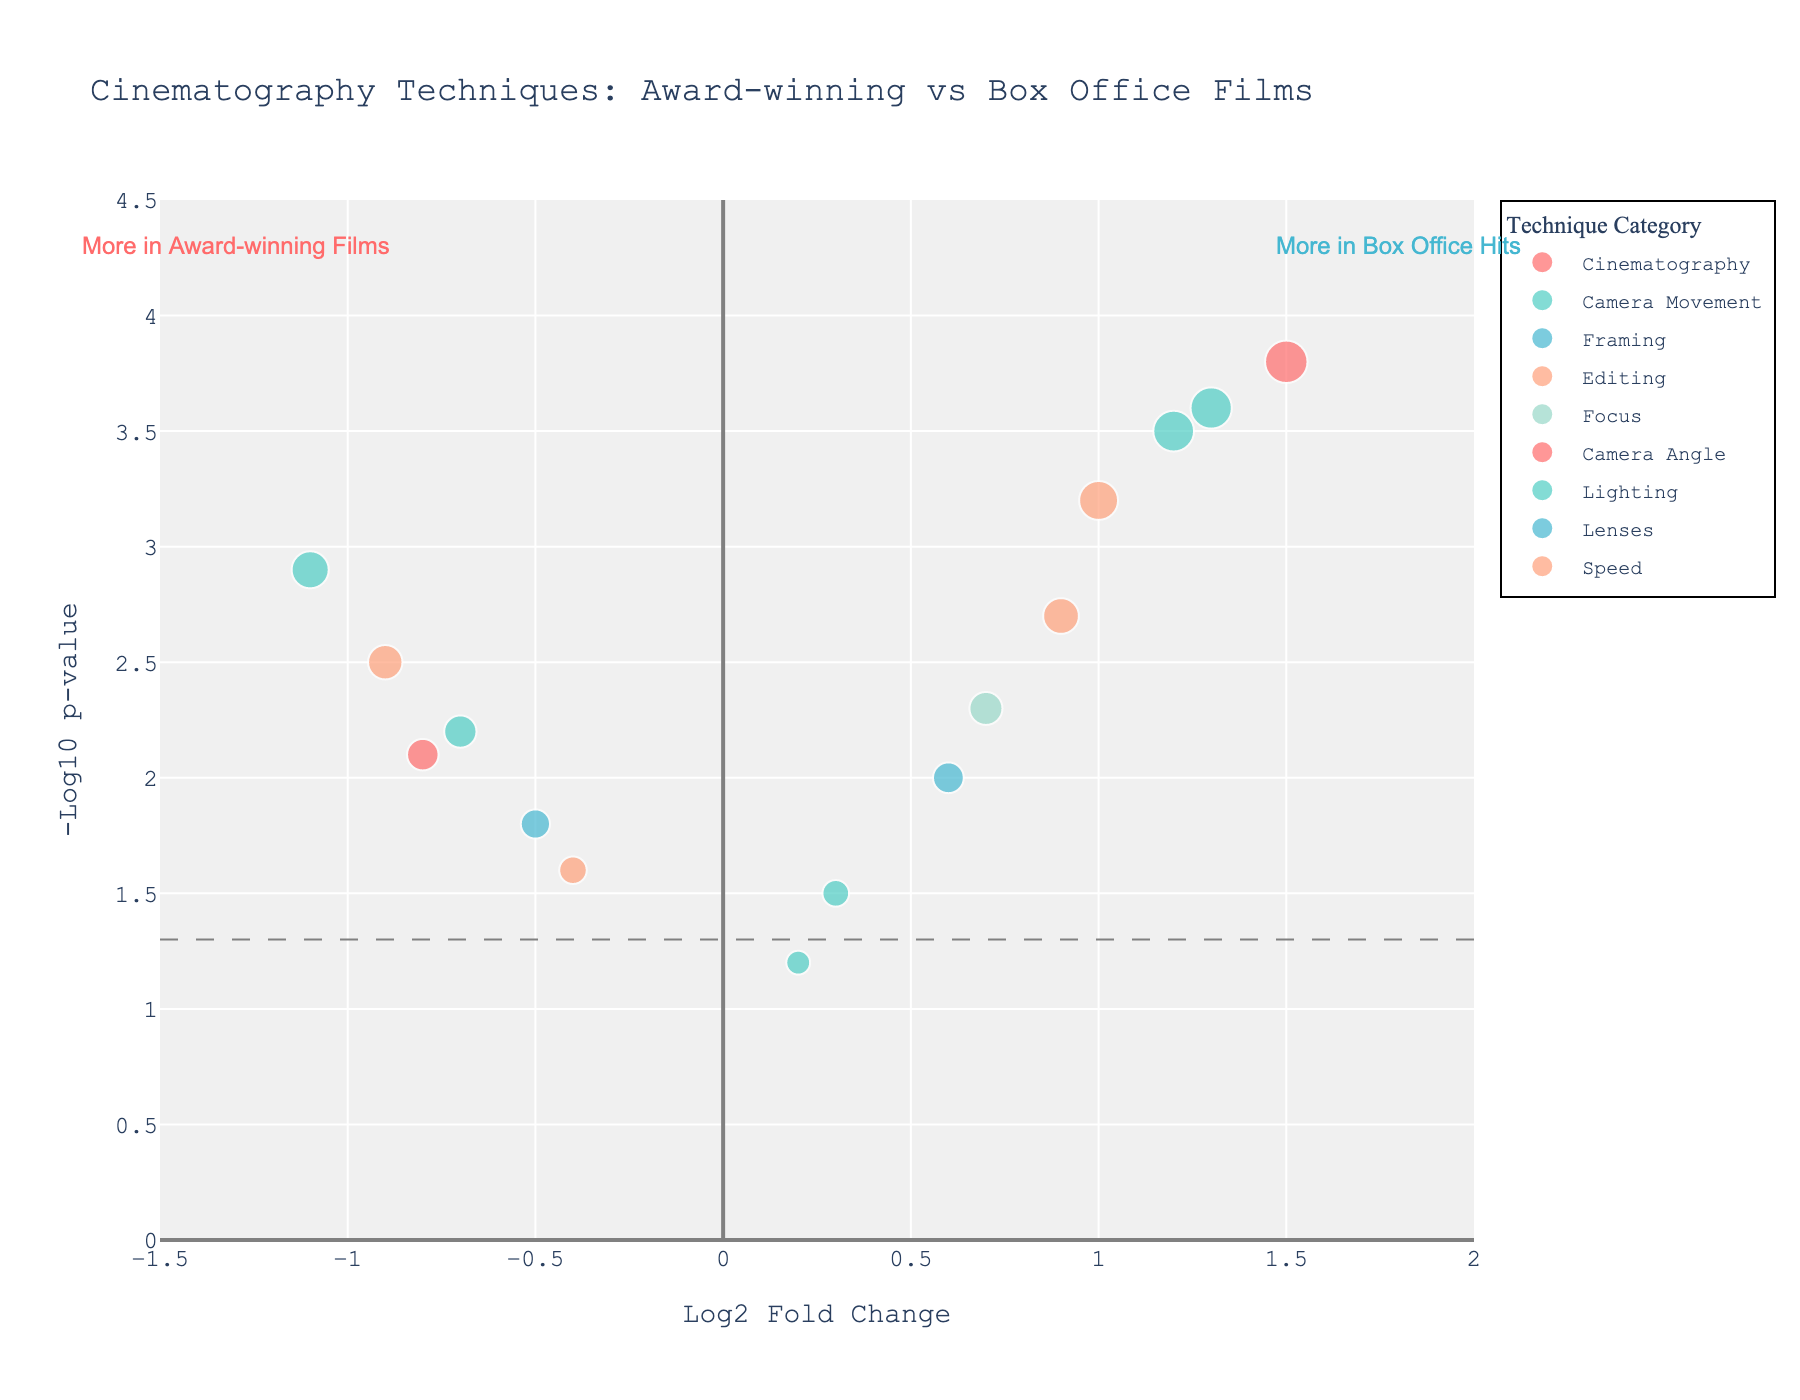How many techniques have a log2 fold change greater than 1? To determine this, look at the x-axis values for log2 fold change and count the number of points with x-values greater than 1. There are four points: Steadicam shots, Aerial shots, Slow motion, and Tracking shots.
Answer: 4 Which cinematography technique has the highest -log10 p-value? The highest -log10 p-value can be identified by looking at the point with the maximum y-value. The technique associated with this point is Aerial shots, with a -log10 p-value of 3.8.
Answer: Aerial shots In which quadrant (relative to x=0 and y=1.3) does the Chiaroscuro lighting fall? Chiaroscuro lighting is at (-1.1, 2.9). Given these coordinates, it falls to the left of x=0 and above y=1.3, placing it in the top-left quadrant.
Answer: Top-left quadrant How many techniques are categorized under Camera Movement, and what are they? Identify the points with the color associated with the Camera Movement category and count them. There are four techniques: Steadicam shots, Handheld camera, Dolly zoom, and Tracking shots.
Answer: 4 (Steadicam shots, Handheld camera, Dolly zoom, Tracking shots) Which technique(s) indicating a preference in award-winning films have a -log10 p-value above 2.0? First, look for techniques with a log2 fold change less than 0 (left side of the plot) and a -log10 p-value greater than 2. They include: Dutch angle, Chiaroscuro lighting, Split-screen, and Low-key lighting.
Answer: Dutch angle, Chiaroscuro lighting, Split-screen, Low-key lighting What is the average -log10 p-value for techniques with log2 fold change less than 0? List the -log10 p-values for techniques with log2 fold change less than 0: Dutch angle (2.1), Extreme close-ups (1.8), Chiaroscuro lighting (2.9), Split-screen (2.5), Jump cuts (1.6), Low-key lighting (2.2). The average is (2.1+1.8+2.9+2.5+1.6+2.2)/6 = 2.18.
Answer: 2.18 Which Lighting technique is closer to the x=0 line? Identify the points associated with the Lighting category and compare their x-values to 0. Chiaroscuro lighting is at -1.1, and Low-key lighting is at -0.7. Low-key lighting is closer to x=0.
Answer: Low-key lighting Do any techniques fall in the top-right quadrant? This requires finding points with a log2 fold change greater than 0 and a -log10 p-value greater than 1.3 (y-axis horizontal line). The techniques in the top-right quadrant are Steadicam shots, Aerial shots, Slow motion, Long takes, Rack focus, and Tracking shots.
Answer: Yes Which Camera Angle technique shows the strongest statistical significance? Among the Camera Angle techniques (identified by color), identify the one with the highest -log10 p-value. Aerial shots has the highest with a value of 3.8.
Answer: Aerial shots 